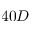<formula> <loc_0><loc_0><loc_500><loc_500>4 0 D</formula> 